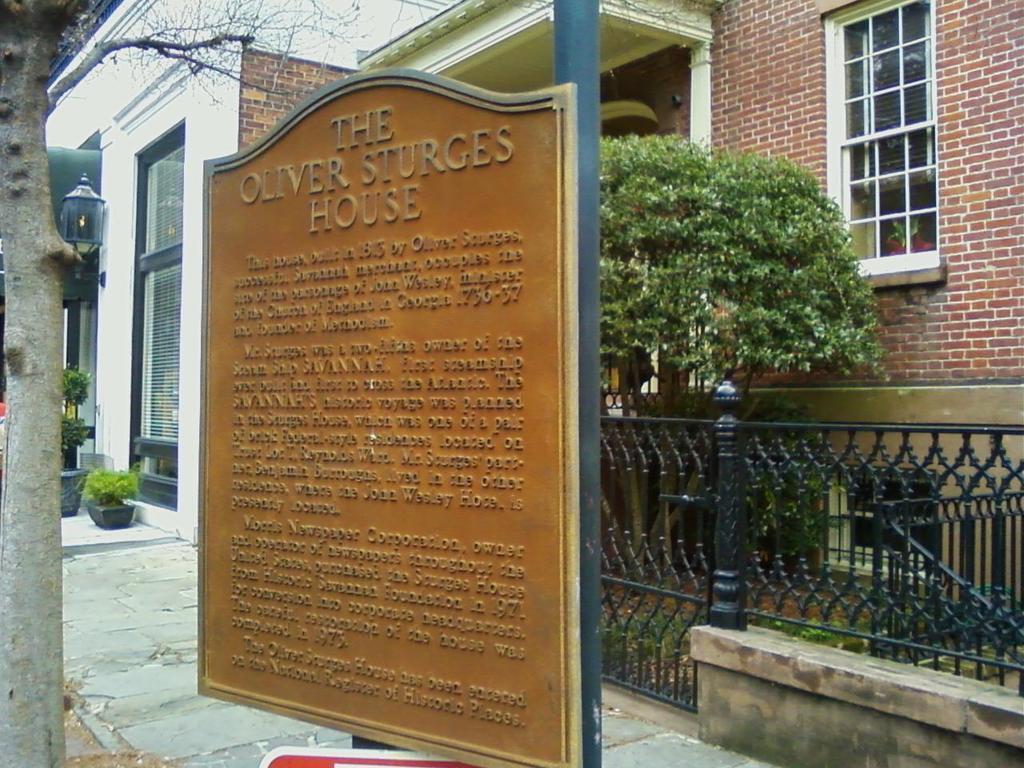Describe this image in one or two sentences. In this picture, we can see a pole with a board and behind the pole there is a path, fence, trees, plants and a building. 